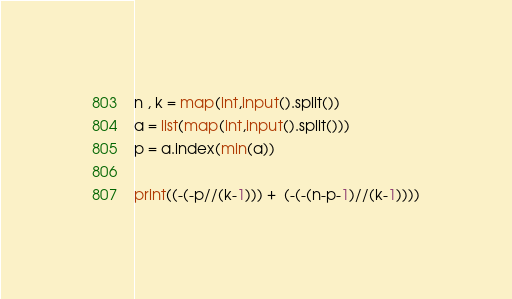Convert code to text. <code><loc_0><loc_0><loc_500><loc_500><_Python_>n , k = map(int,input().split())
a = list(map(int,input().split()))
p = a.index(min(a))

print((-(-p//(k-1))) +  (-(-(n-p-1)//(k-1))))</code> 